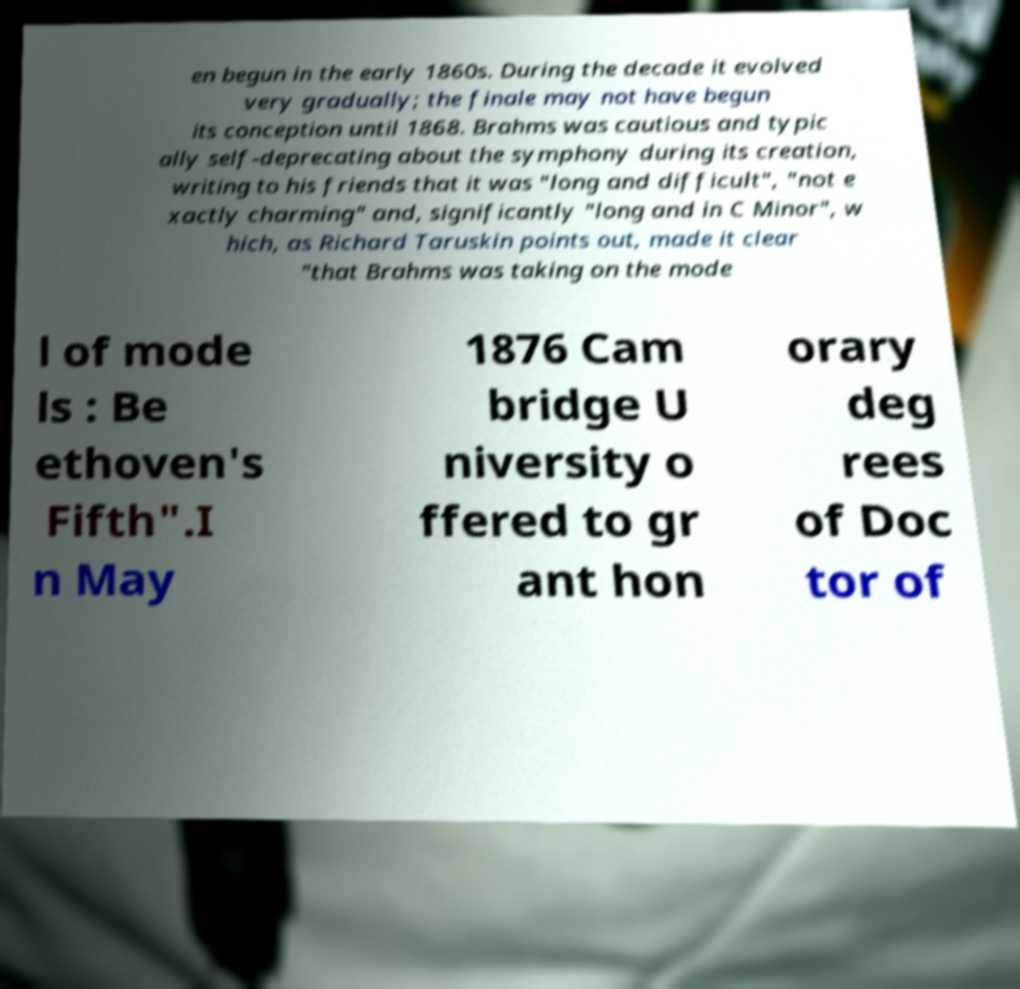Can you accurately transcribe the text from the provided image for me? en begun in the early 1860s. During the decade it evolved very gradually; the finale may not have begun its conception until 1868. Brahms was cautious and typic ally self-deprecating about the symphony during its creation, writing to his friends that it was "long and difficult", "not e xactly charming" and, significantly "long and in C Minor", w hich, as Richard Taruskin points out, made it clear "that Brahms was taking on the mode l of mode ls : Be ethoven's Fifth".I n May 1876 Cam bridge U niversity o ffered to gr ant hon orary deg rees of Doc tor of 